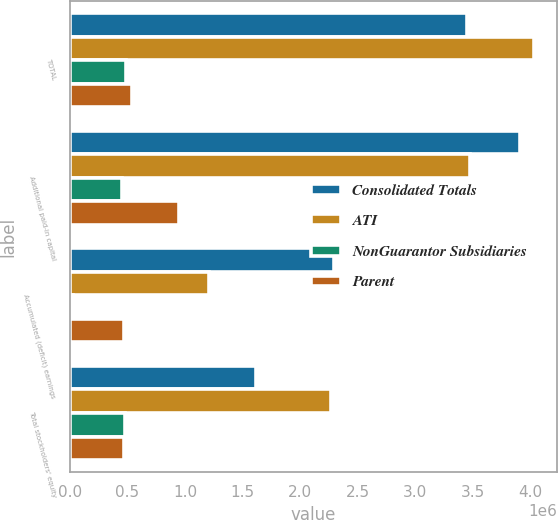Convert chart to OTSL. <chart><loc_0><loc_0><loc_500><loc_500><stacked_bar_chart><ecel><fcel>TOTAL<fcel>Additional paid-in capital<fcel>Accumulated (deficit) earnings<fcel>Total stockholders' equity<nl><fcel>Consolidated Totals<fcel>3.45027e+06<fcel>3.91088e+06<fcel>2.29182e+06<fcel>1.6169e+06<nl><fcel>ATI<fcel>4.0357e+06<fcel>3.47558e+06<fcel>1.20815e+06<fcel>2.26743e+06<nl><fcel>NonGuarantor Subsidiaries<fcel>485875<fcel>453013<fcel>24446<fcel>477459<nl><fcel>Parent<fcel>539418<fcel>946328<fcel>470607<fcel>469001<nl></chart> 